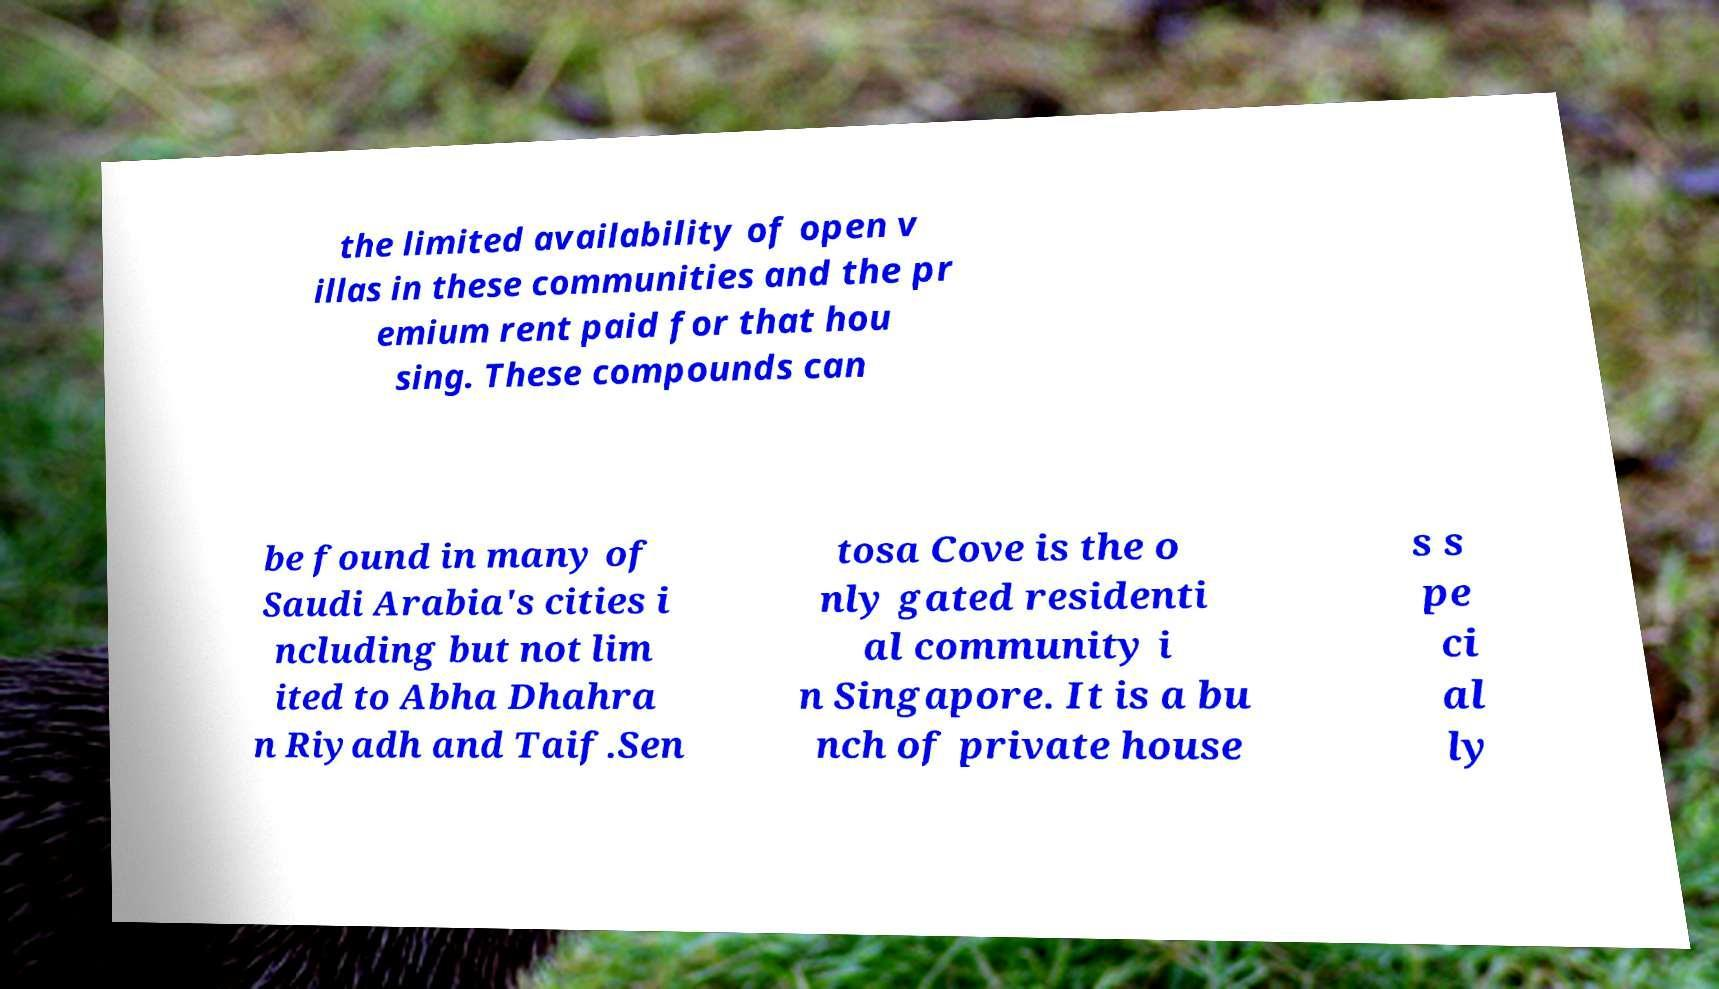For documentation purposes, I need the text within this image transcribed. Could you provide that? the limited availability of open v illas in these communities and the pr emium rent paid for that hou sing. These compounds can be found in many of Saudi Arabia's cities i ncluding but not lim ited to Abha Dhahra n Riyadh and Taif.Sen tosa Cove is the o nly gated residenti al community i n Singapore. It is a bu nch of private house s s pe ci al ly 